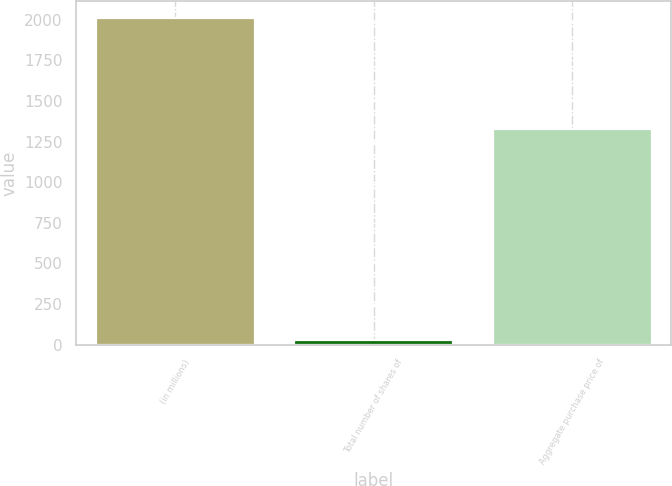Convert chart. <chart><loc_0><loc_0><loc_500><loc_500><bar_chart><fcel>(in millions)<fcel>Total number of shares of<fcel>Aggregate purchase price of<nl><fcel>2012<fcel>31<fcel>1329<nl></chart> 